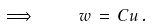Convert formula to latex. <formula><loc_0><loc_0><loc_500><loc_500>\implies \quad w \, = \, C u \, .</formula> 